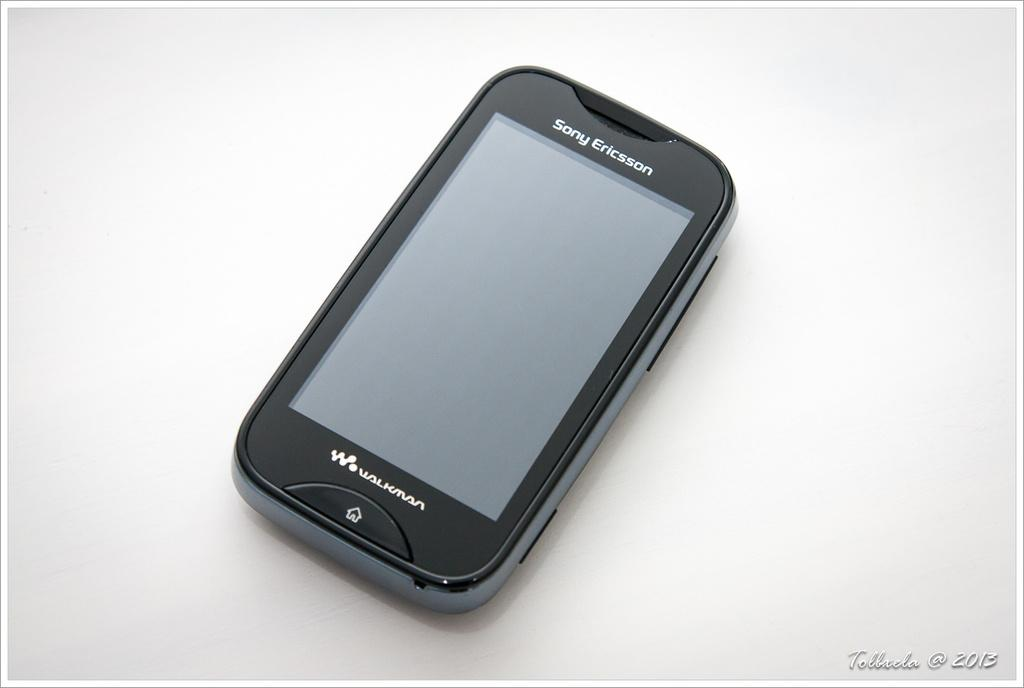<image>
Provide a brief description of the given image. A black Sony Ericsson walkman phone against a white backdrop. 